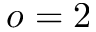Convert formula to latex. <formula><loc_0><loc_0><loc_500><loc_500>o = 2</formula> 